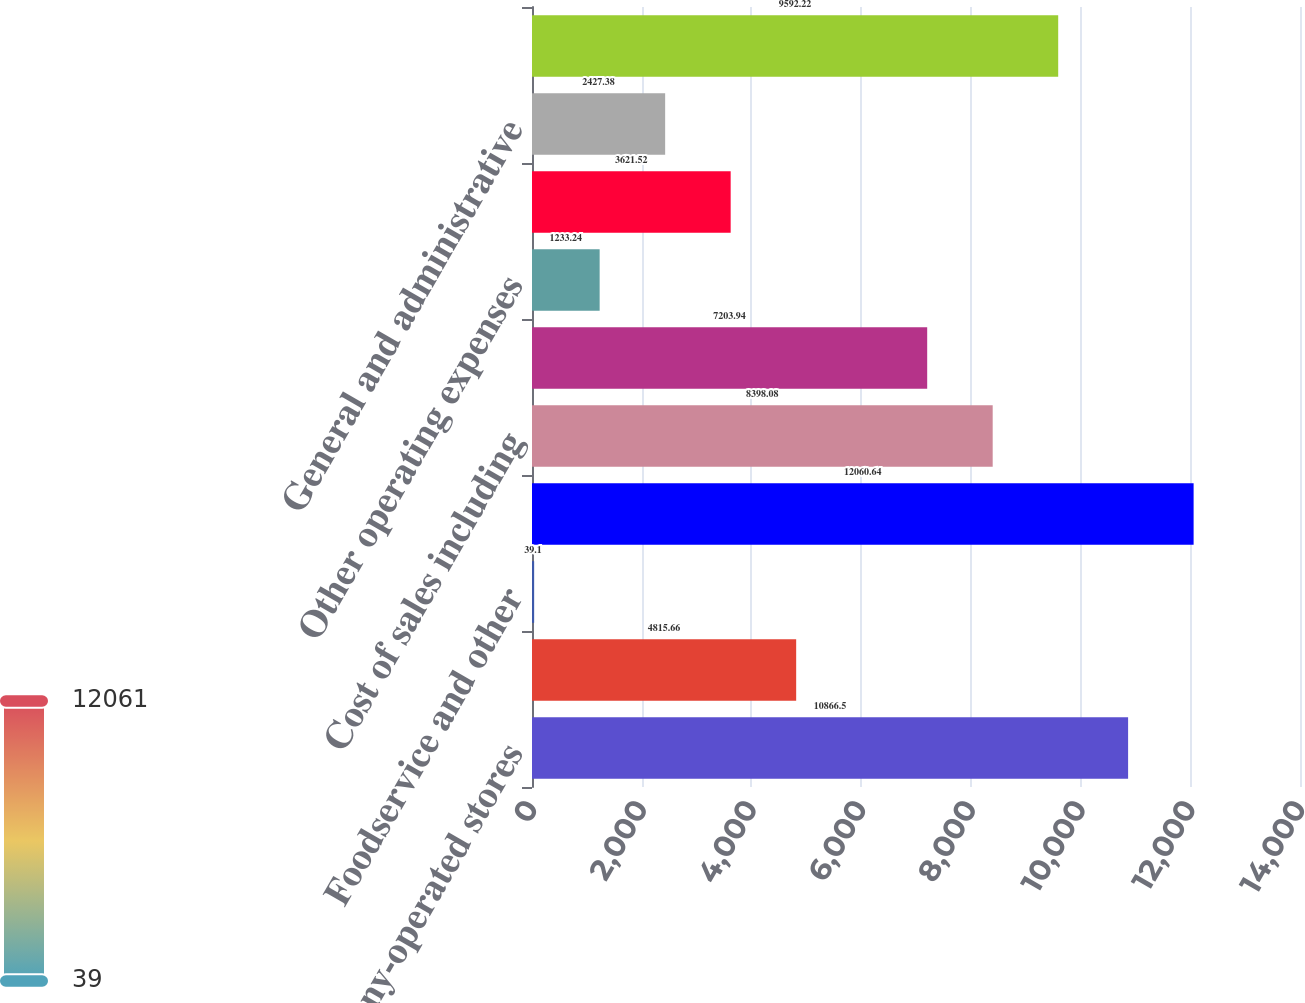<chart> <loc_0><loc_0><loc_500><loc_500><bar_chart><fcel>Company-operated stores<fcel>Licensed stores<fcel>Foodservice and other<fcel>Total net revenues<fcel>Cost of sales including<fcel>Store operating expenses<fcel>Other operating expenses<fcel>Depreciation and amortization<fcel>General and administrative<fcel>Total operating expenses<nl><fcel>10866.5<fcel>4815.66<fcel>39.1<fcel>12060.6<fcel>8398.08<fcel>7203.94<fcel>1233.24<fcel>3621.52<fcel>2427.38<fcel>9592.22<nl></chart> 